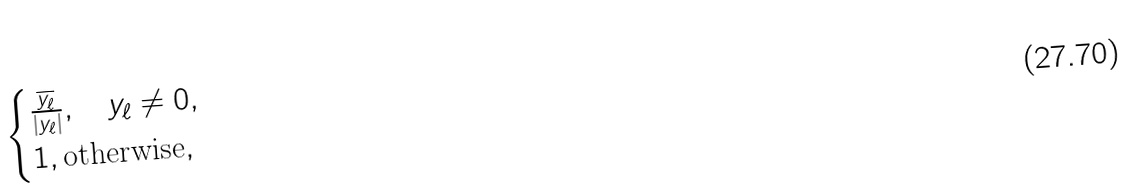<formula> <loc_0><loc_0><loc_500><loc_500>\begin{cases} \frac { \overline { y _ { \ell } } } { | y _ { \ell } | } , \quad y _ { \ell } \neq 0 , \\ 1 , \text {otherwise} , \end{cases}</formula> 